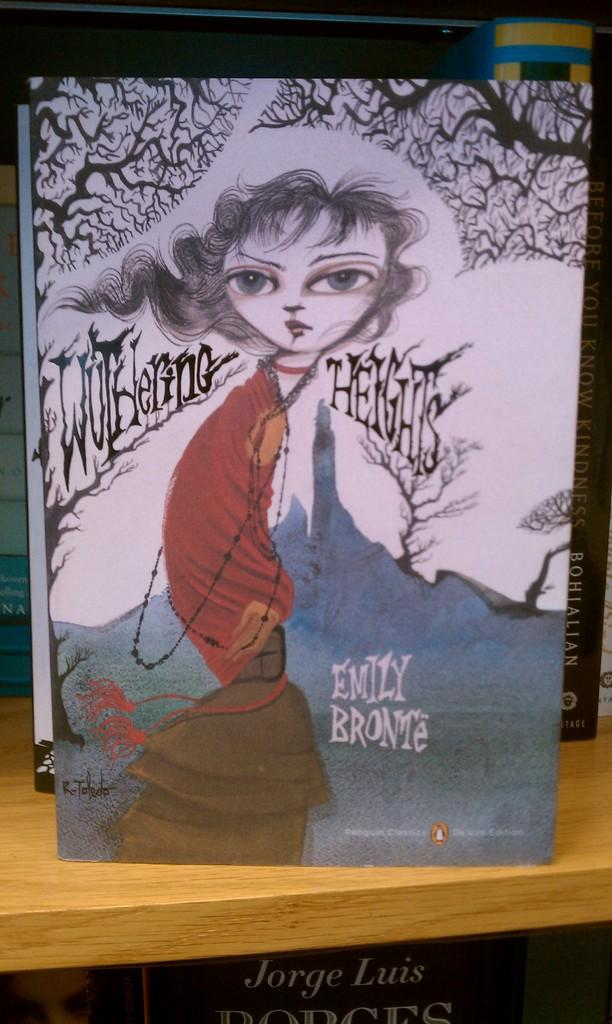<image>
Present a compact description of the photo's key features. An Emily Bronte novel sits on display on a shelf 